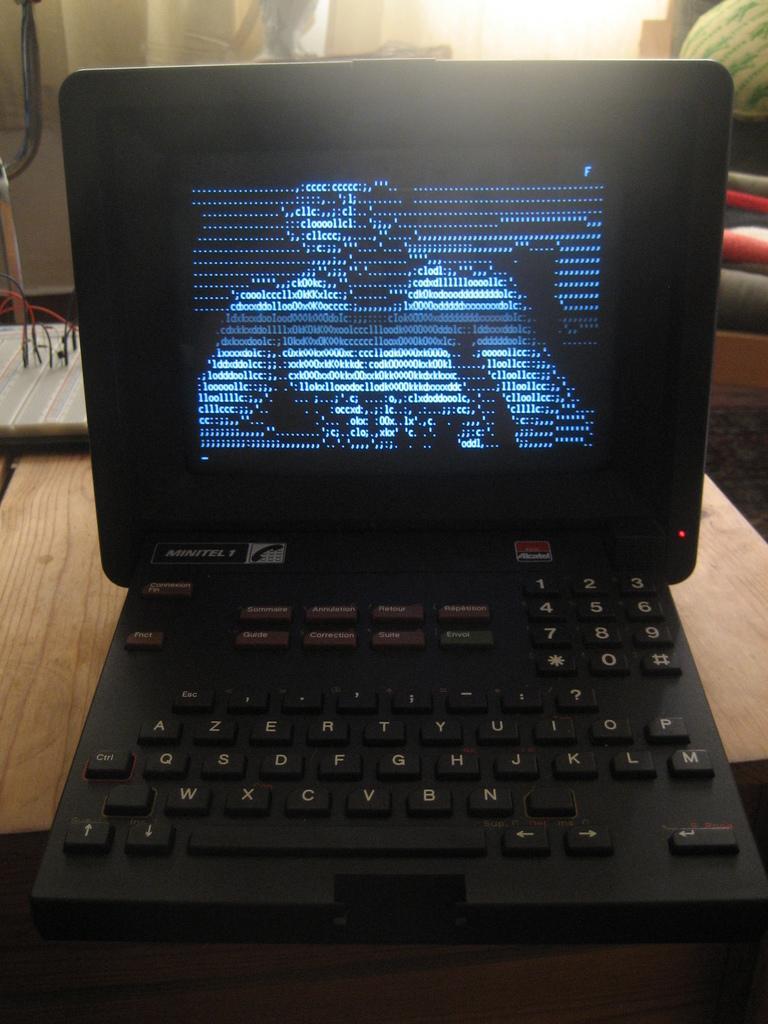Describe this image in one or two sentences. This is the picture of a table on which there is a laptop and behind there are some other things. 